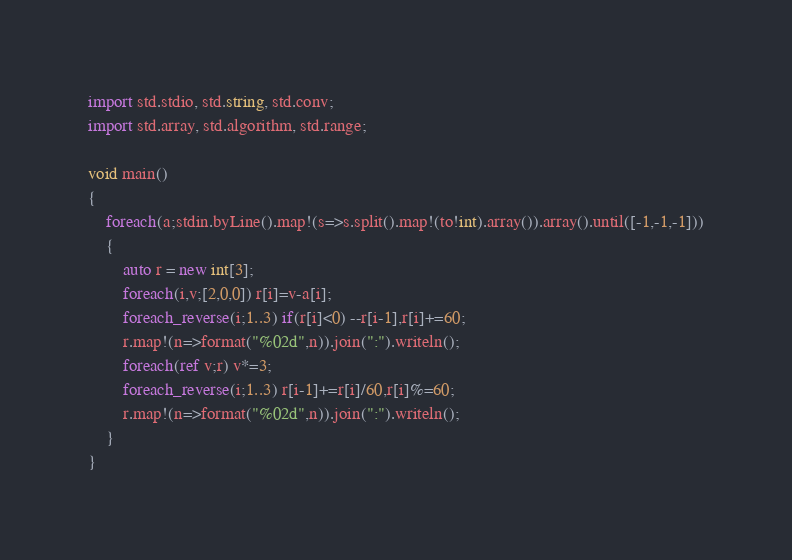<code> <loc_0><loc_0><loc_500><loc_500><_D_>import std.stdio, std.string, std.conv;
import std.array, std.algorithm, std.range;

void main()
{
    foreach(a;stdin.byLine().map!(s=>s.split().map!(to!int).array()).array().until([-1,-1,-1]))
    {
        auto r = new int[3];
        foreach(i,v;[2,0,0]) r[i]=v-a[i];
        foreach_reverse(i;1..3) if(r[i]<0) --r[i-1],r[i]+=60;
        r.map!(n=>format("%02d",n)).join(":").writeln();
        foreach(ref v;r) v*=3;
        foreach_reverse(i;1..3) r[i-1]+=r[i]/60,r[i]%=60;
        r.map!(n=>format("%02d",n)).join(":").writeln();
    }
}</code> 